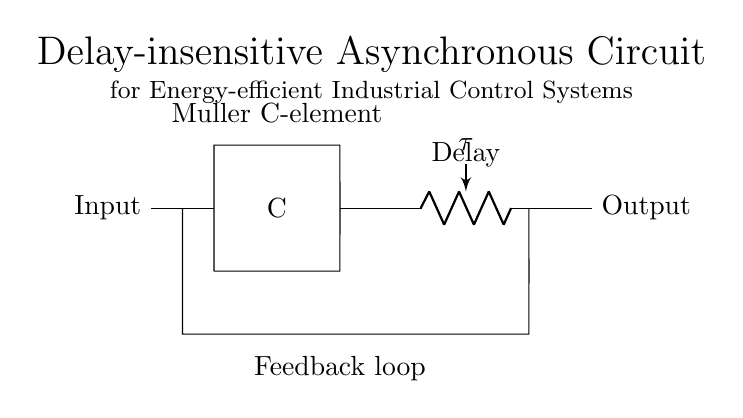What is the main type of component used in this circuit? The main component used in this circuit is the Muller C-element, which is a fundamental element in asynchronous circuits for synchronization.
Answer: Muller C-element What does the delay element represent in the circuit? The delay element indicates the amount of time the circuit takes to respond to inputs, represented as a resistor labeled with the time constant tau.
Answer: tau How many inputs does the Muller C-element have? The Muller C-element typically has two inputs, which are required for its operation, as implied by its representation in the diagram.
Answer: Two What is the function of the feedback loop in this circuit? The feedback loop allows the output to affect the input, ensuring stability and synchronization in the asynchronous circuit operation.
Answer: Stability What type of circuit is represented in this diagram? The circuit is classified as a delay-insensitive asynchronous circuit, which is designed to eliminate timing dependencies.
Answer: Delay-insensitive asynchronous What is the significance of the output in terms of energy efficiency? The output signifies the reduced energy consumption by handling inputs asynchronously, thus minimizing delays and energy waste in industrial control systems.
Answer: Energy efficiency What is the name of the circuit element labeled with "C"? The element labeled with "C" is the C-element, which is a crucial component in asynchronous systems, as it allows for the detection of stable states based on input signals.
Answer: C-element 